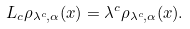Convert formula to latex. <formula><loc_0><loc_0><loc_500><loc_500>L _ { c } \rho _ { \lambda ^ { c } , \alpha } ( { x } ) = \lambda ^ { c } \rho _ { \lambda ^ { c } , \alpha } ( { x } ) .</formula> 